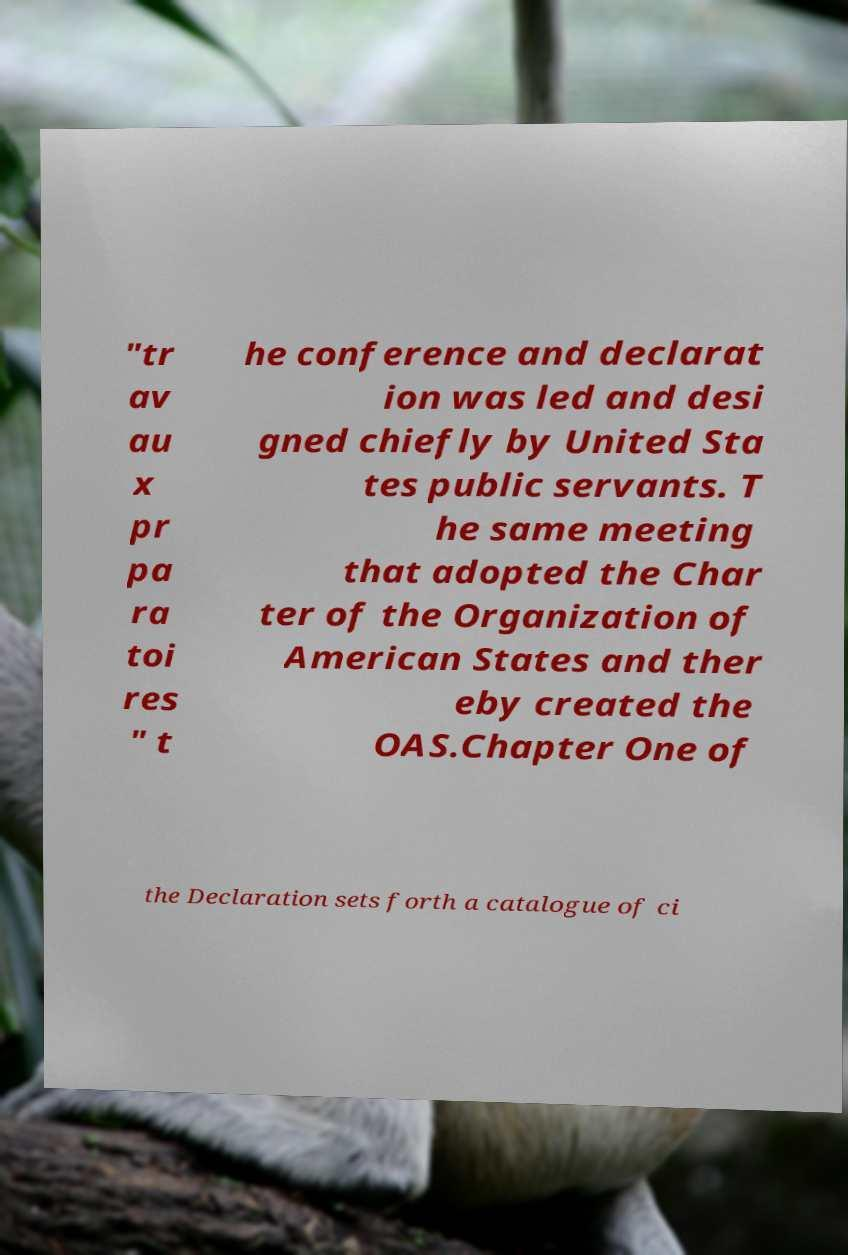I need the written content from this picture converted into text. Can you do that? "tr av au x pr pa ra toi res " t he conference and declarat ion was led and desi gned chiefly by United Sta tes public servants. T he same meeting that adopted the Char ter of the Organization of American States and ther eby created the OAS.Chapter One of the Declaration sets forth a catalogue of ci 